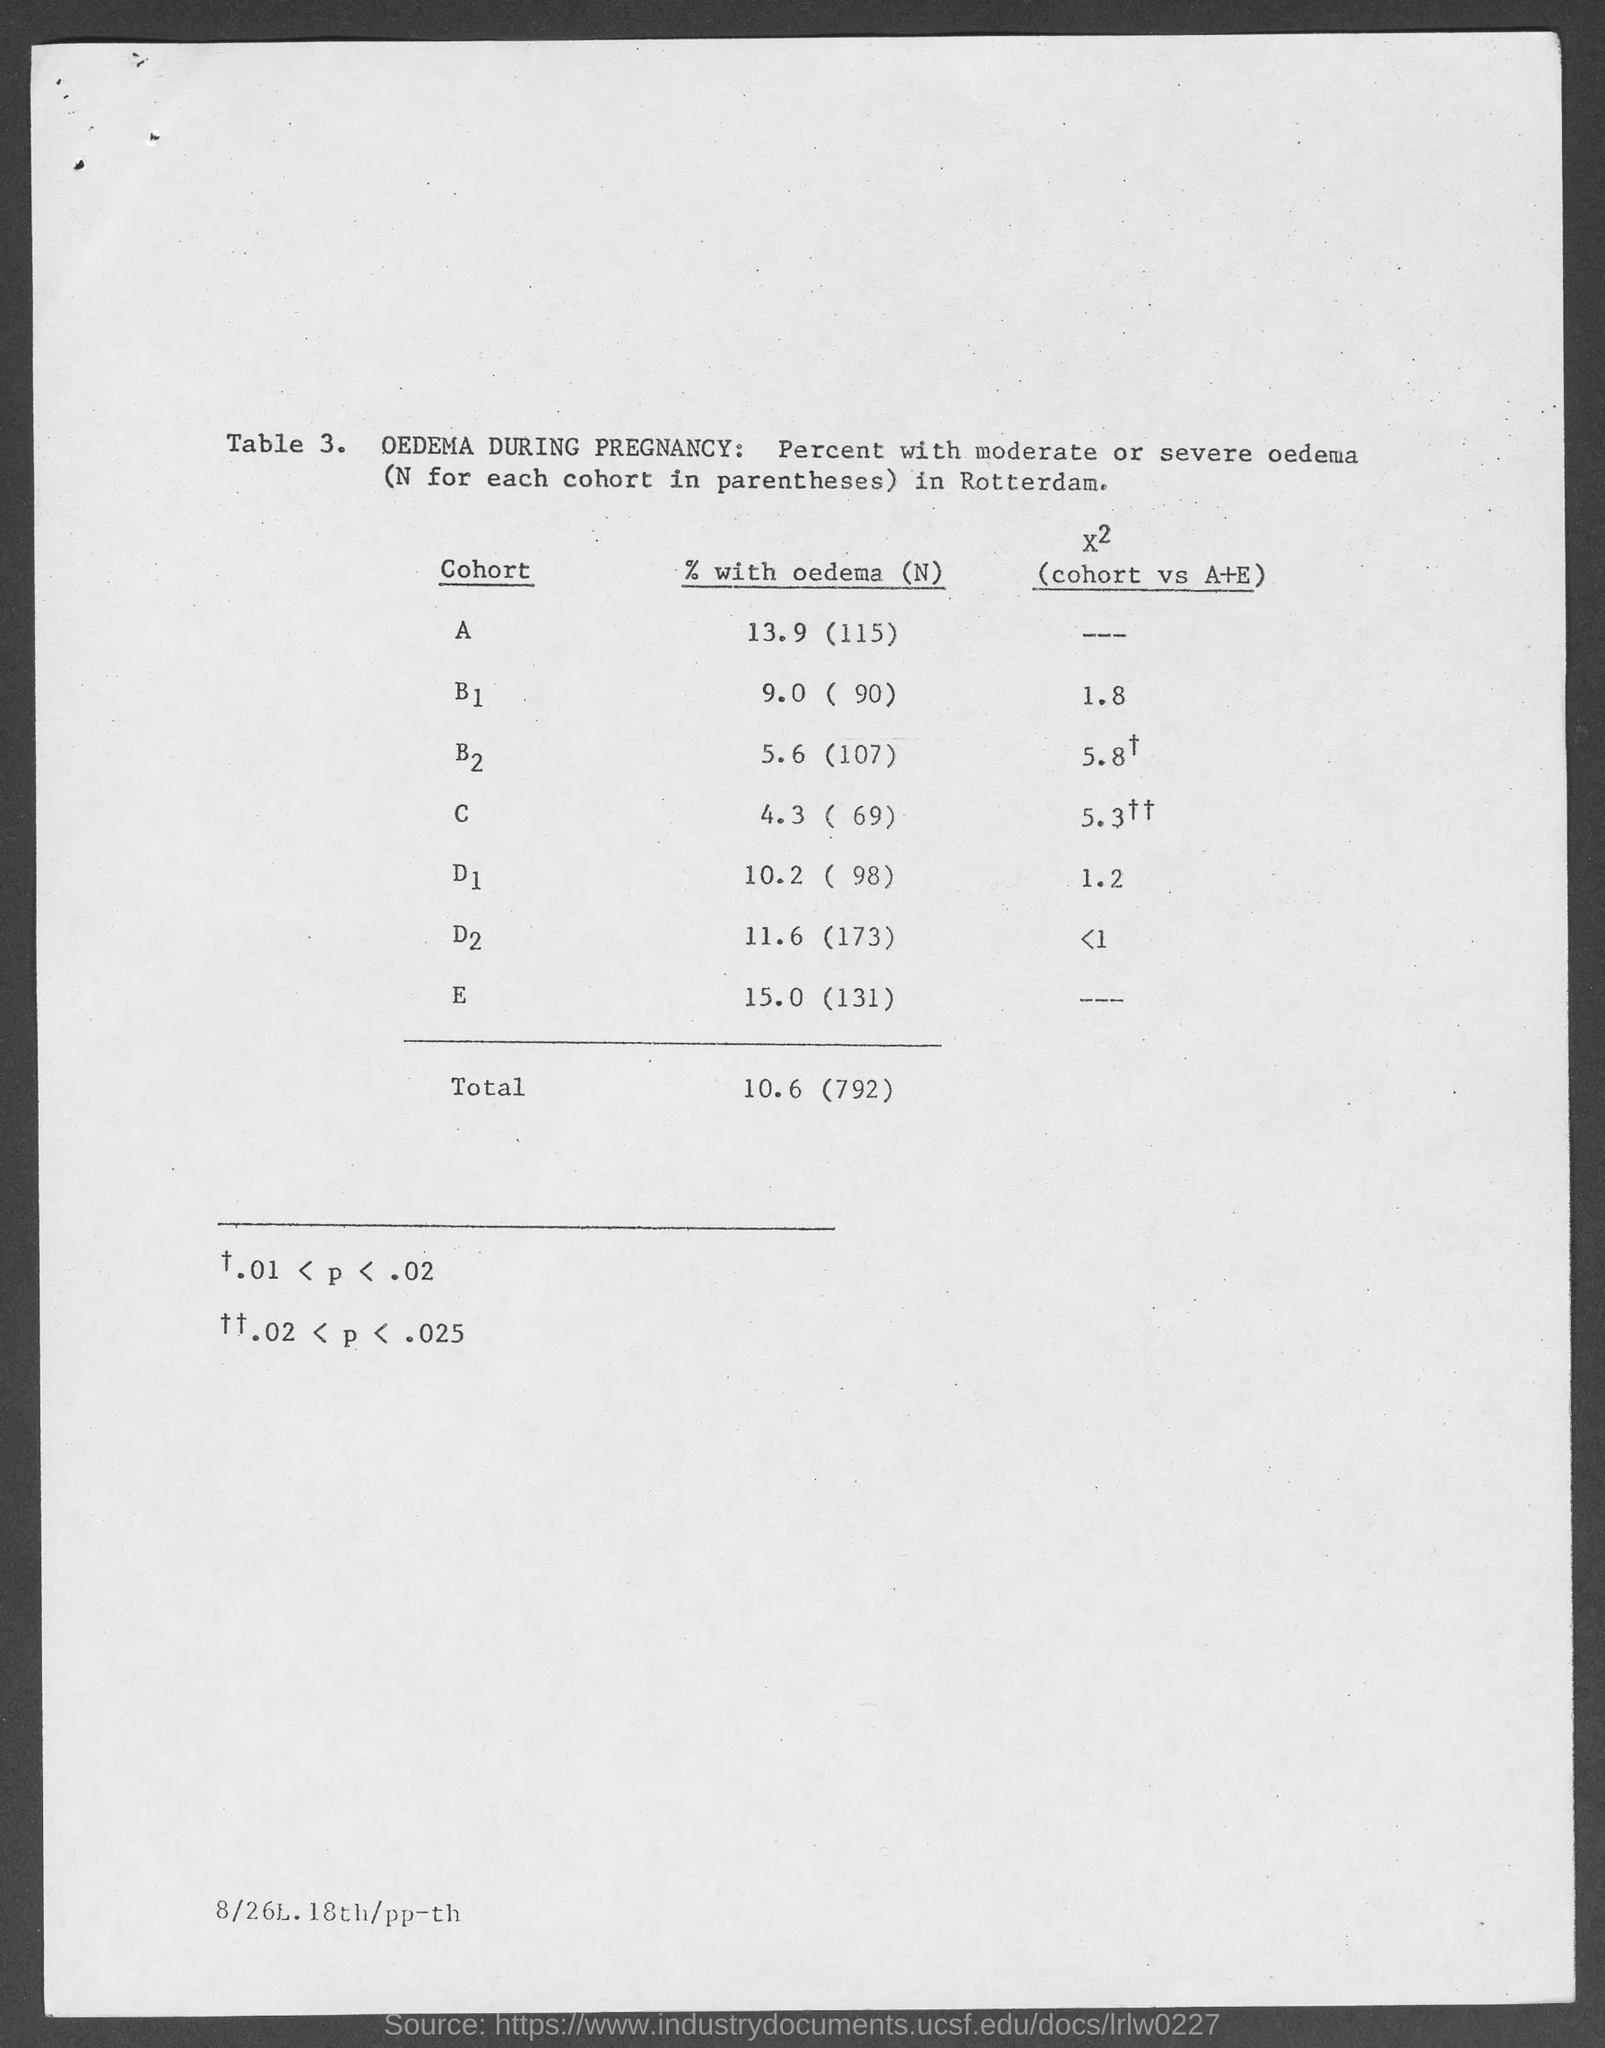What is the % with oedema (n) in cohort a?
Offer a very short reply. 13.9 (115). What is the total of % with oedema (n) ?
Make the answer very short. 10.6 (792). 